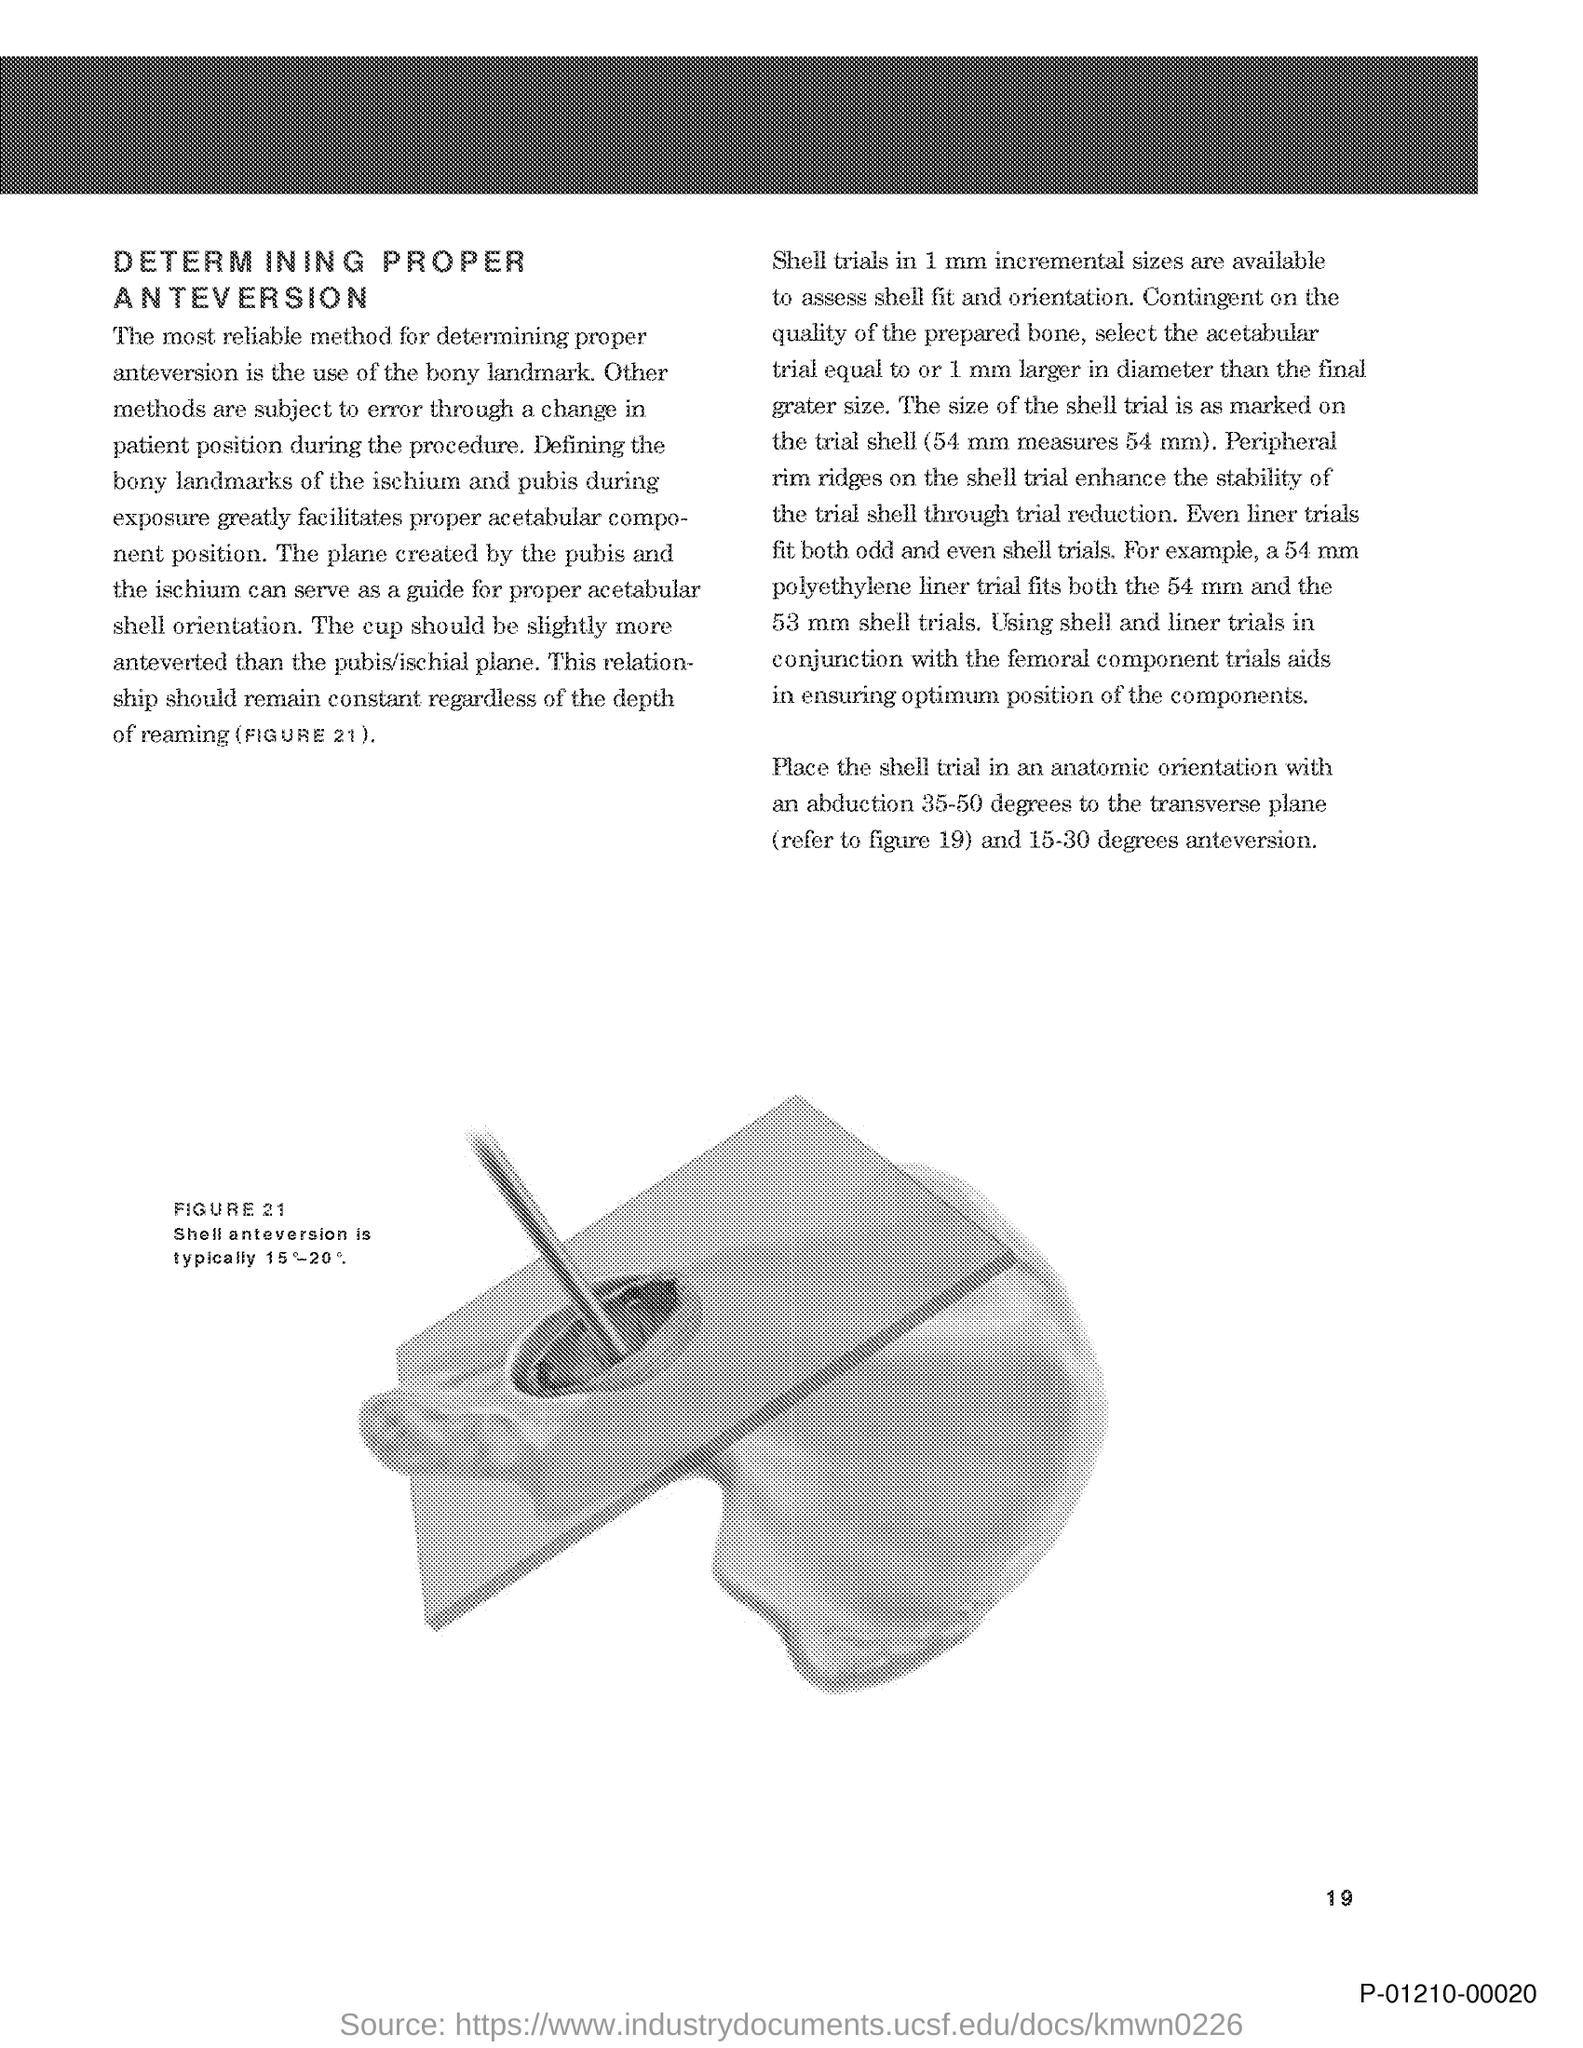What is the Page Number?
Your response must be concise. 19. 